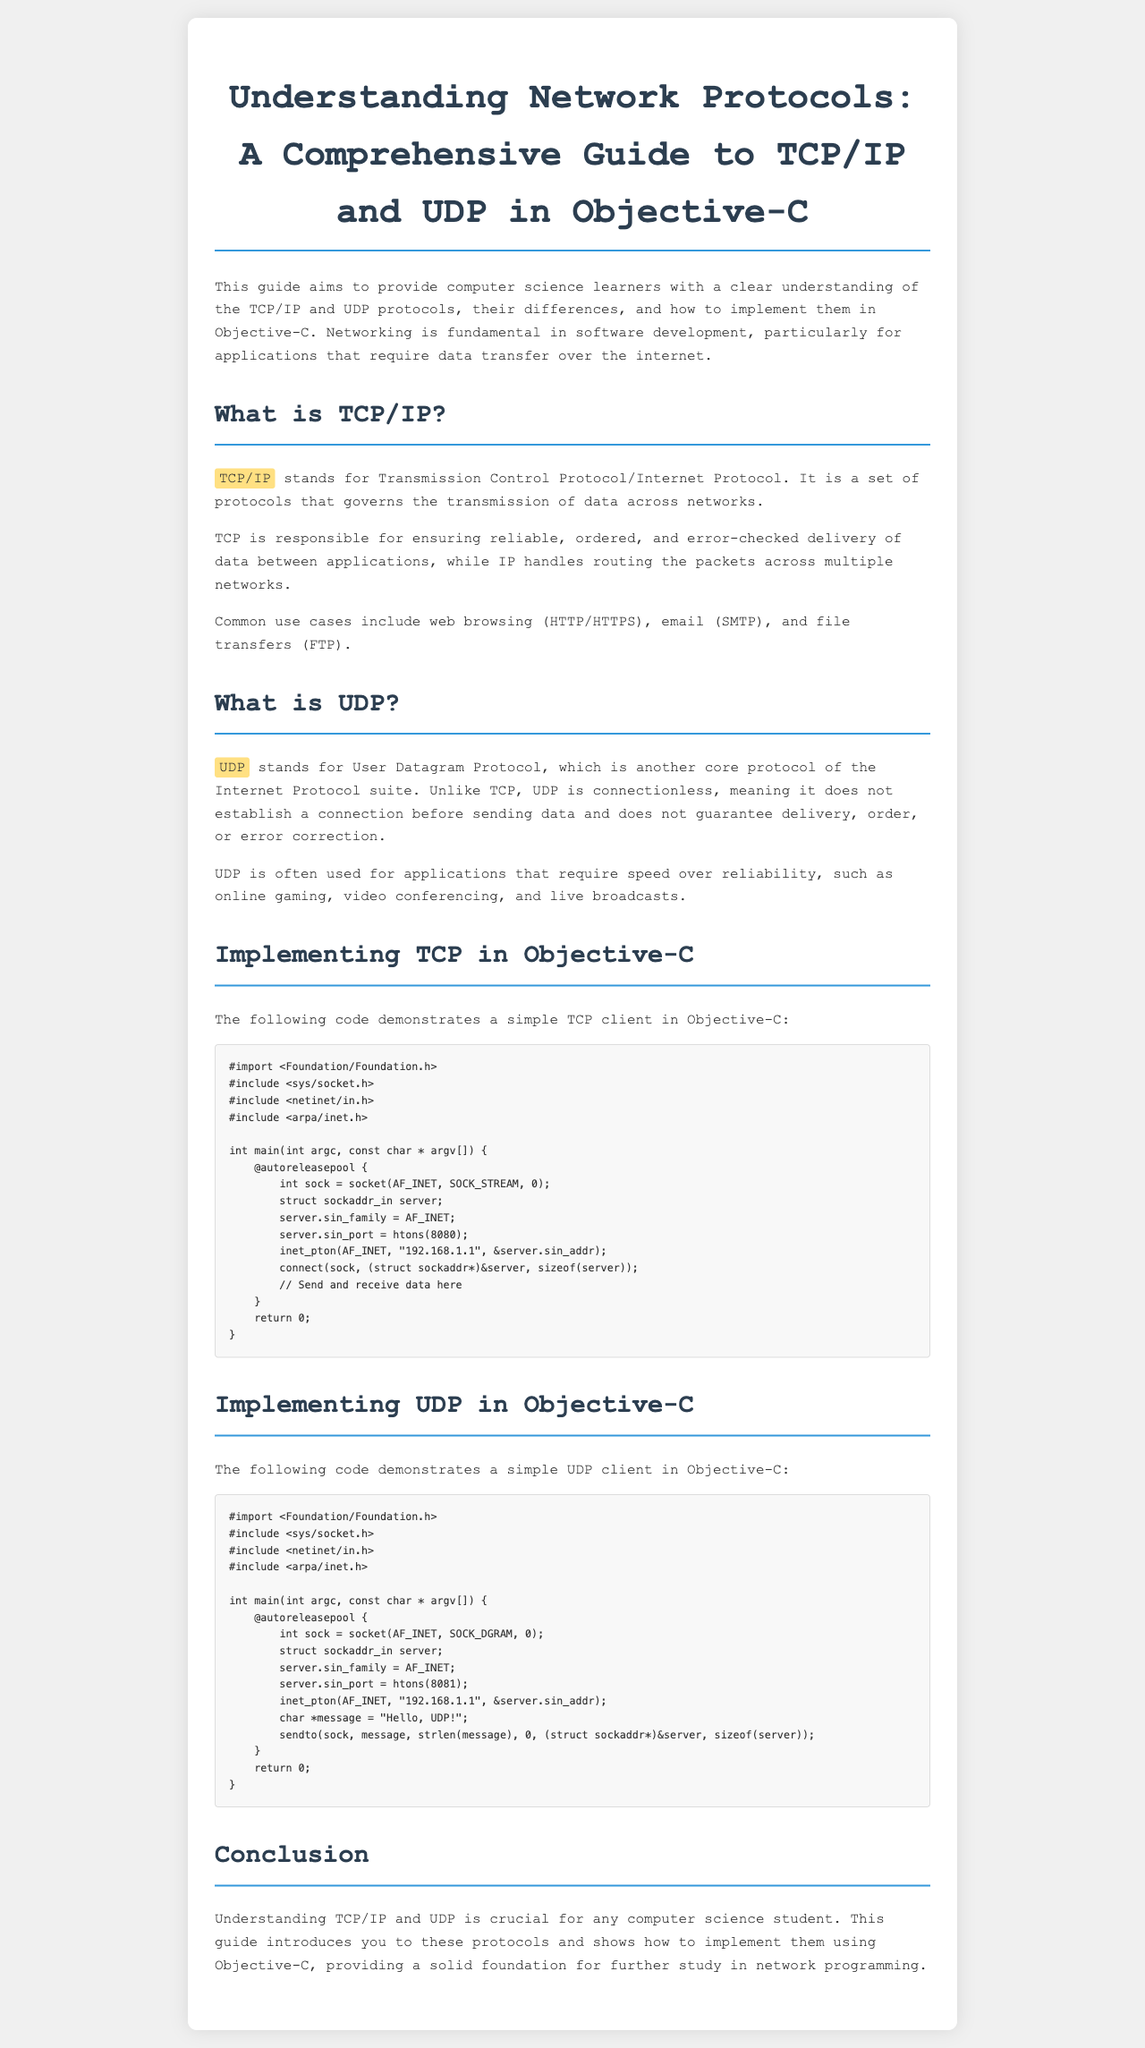What does TCP stand for? TCP is an acronym for Transmission Control Protocol, which is mentioned in the first part of the document.
Answer: Transmission Control Protocol What is the port number for the TCP implementation example? The document provides the port number used in the TCP example, which is shown as 8080 in the code section.
Answer: 8080 What is the main difference between TCP and UDP? The document highlights that TCP is responsible for reliable delivery while UDP is connectionless and does not guarantee delivery, showcasing the differences between these protocols.
Answer: Reliability What protocol is often used for online gaming? According to the guide, UDP is commonly used for applications requiring speed over reliability, such as online gaming.
Answer: UDP What does UDP stand for? The acronym UDP refers to User Datagram Protocol, which is defined in the document.
Answer: User Datagram Protocol What is the function of the inet_pton in the sample code? The document implies that inet_pton is used to convert IP address from text to binary form, related to both TCP and UDP examples.
Answer: Convert IP address What is the purpose of this guide? The guide’s purpose is stated at the beginning, which is to provide learners with a clear understanding of network protocols and their implementation.
Answer: Understanding network protocols What is the main focus of the conclusion section? The conclusion summarizes the importance of understanding TCP/IP and UDP in relation to computer science students, emphasizing the foundation for further study.
Answer: Importance of study What kind of applications commonly utilize TCP? The document lists web browsing, email, and file transfers as common uses of TCP.
Answer: Web browsing, email, file transfers 